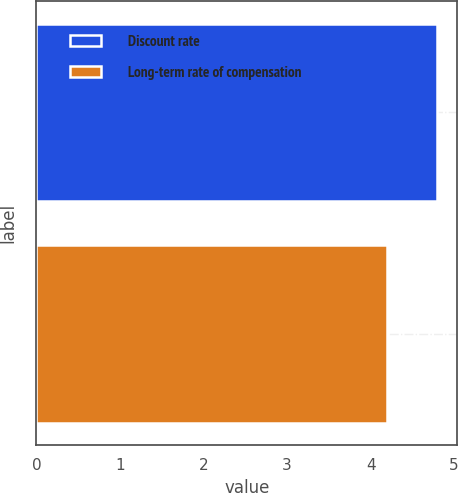<chart> <loc_0><loc_0><loc_500><loc_500><bar_chart><fcel>Discount rate<fcel>Long-term rate of compensation<nl><fcel>4.8<fcel>4.2<nl></chart> 